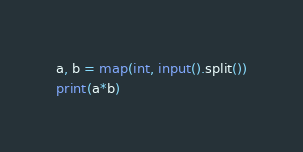Convert code to text. <code><loc_0><loc_0><loc_500><loc_500><_Python_>a, b = map(int, input().split())
print(a*b)</code> 